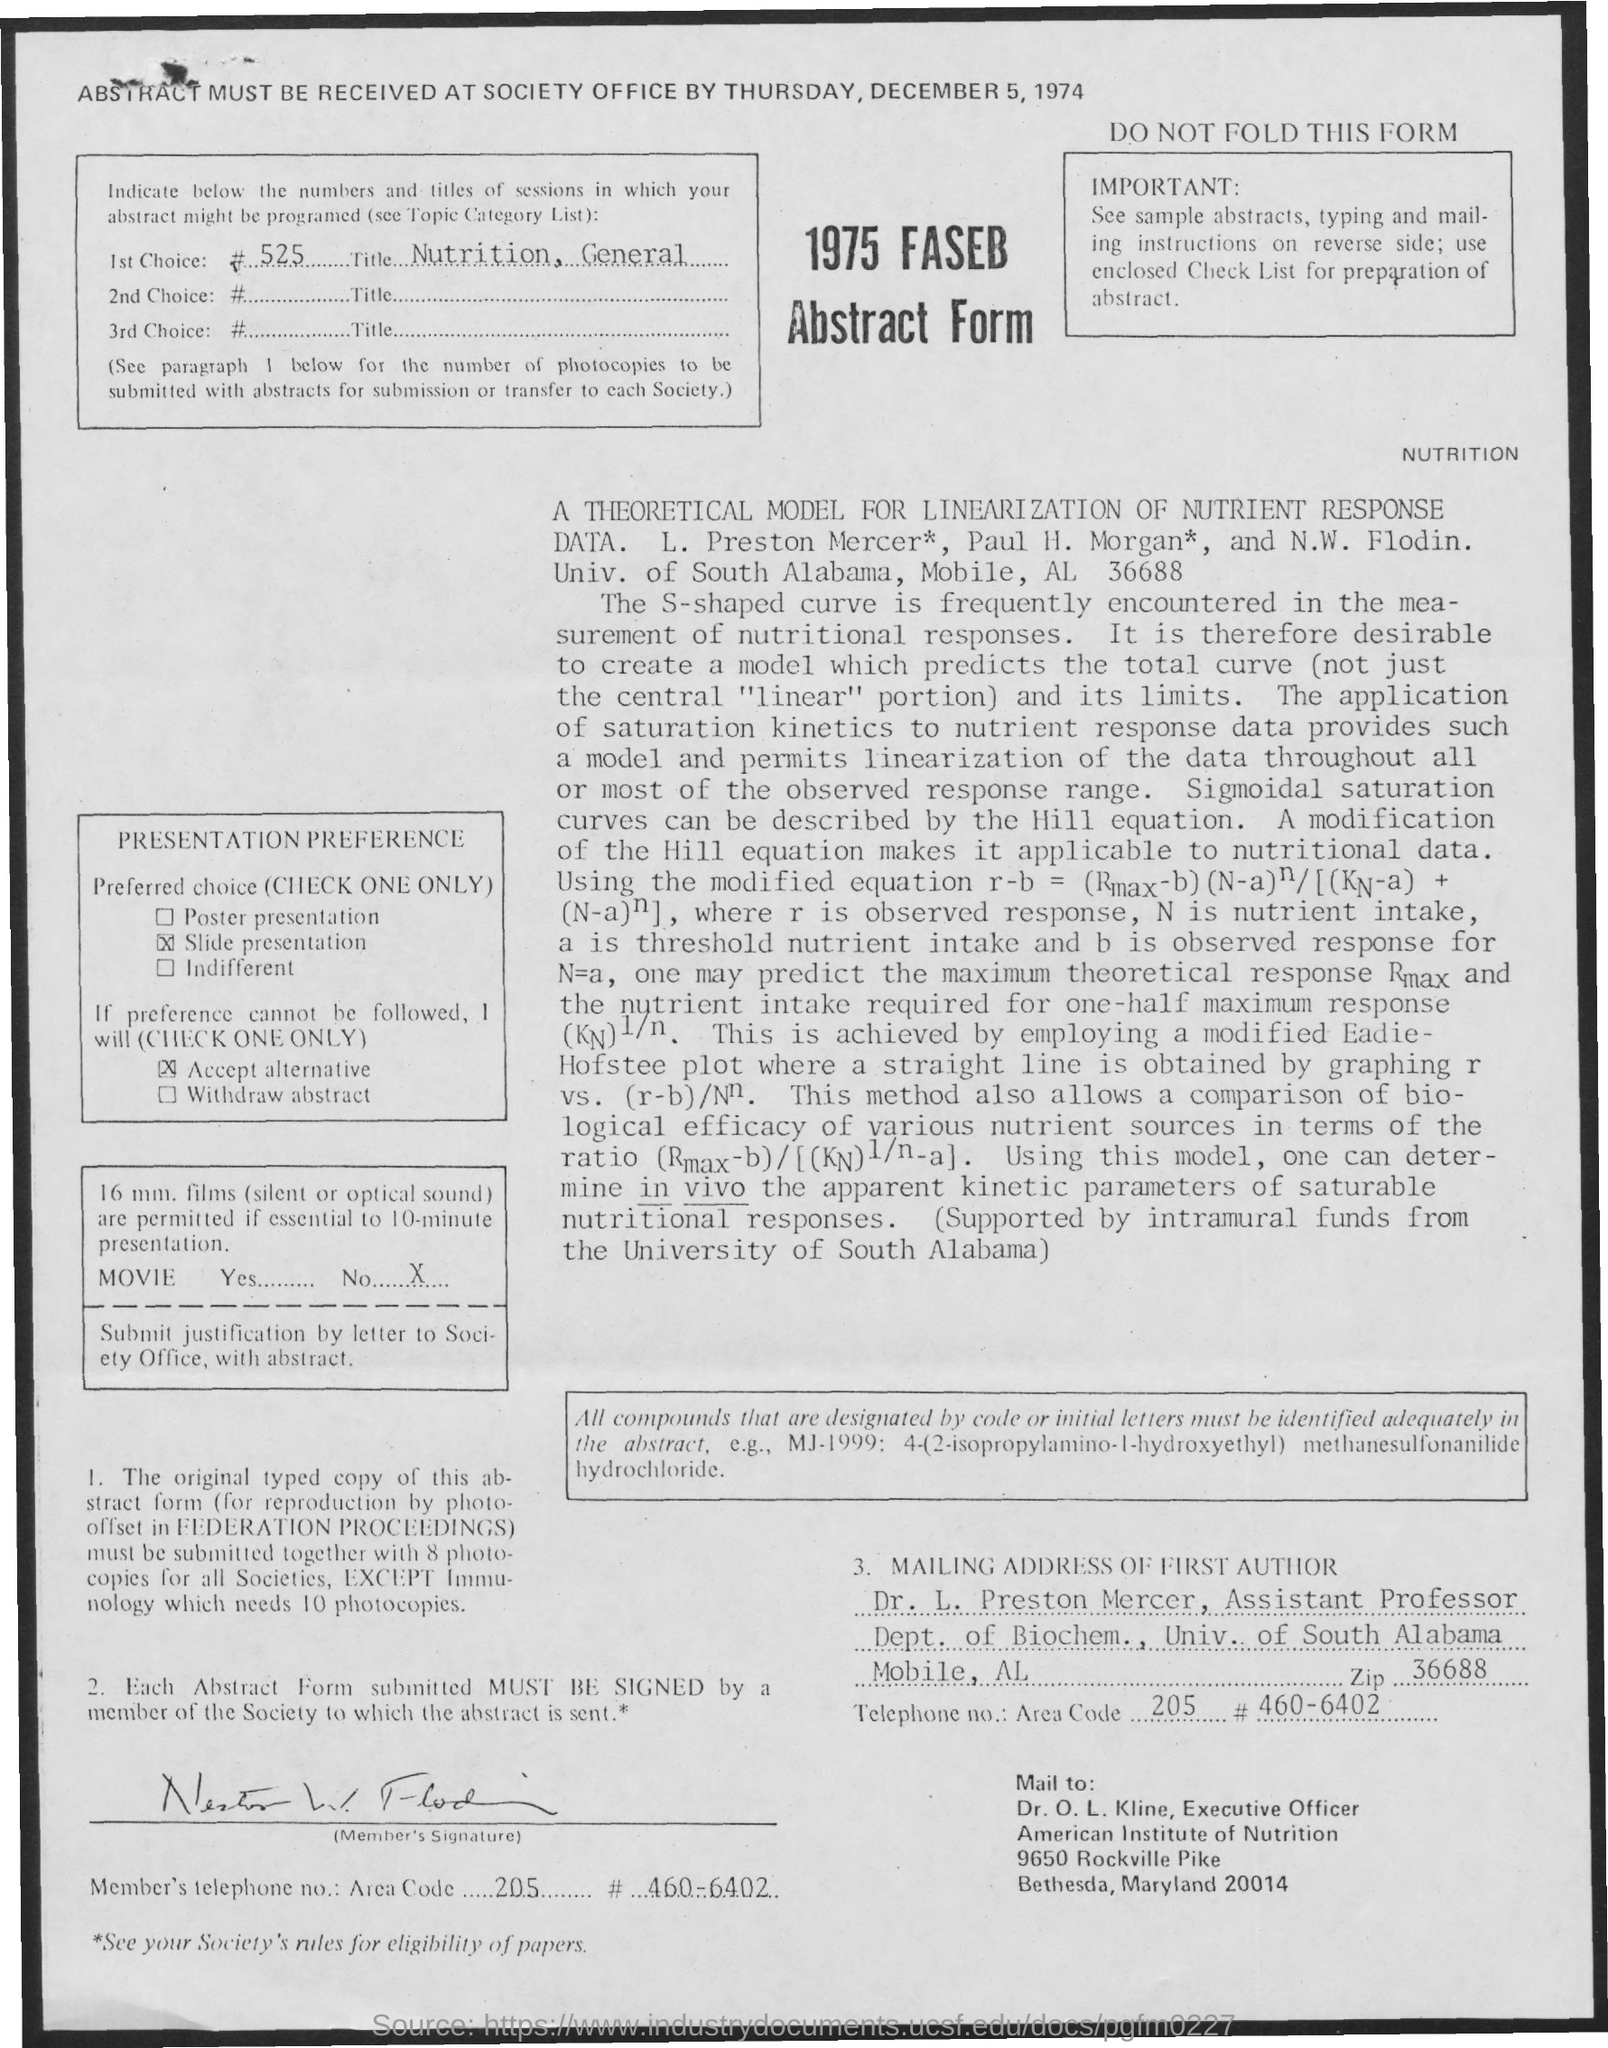Highlight a few significant elements in this photo. What is the zip code associated with the mailing address of the first author, specifically 36688...? Dr. O.L. Kline holds the designation of an executive officer. The mailing address of the first author includes the name of the University of South Alabama. The first author's mailing address contains the name of Dr. L. Preston Mercer. Dr. L. P. Mercer's designation is that of an Assistant Professor. 